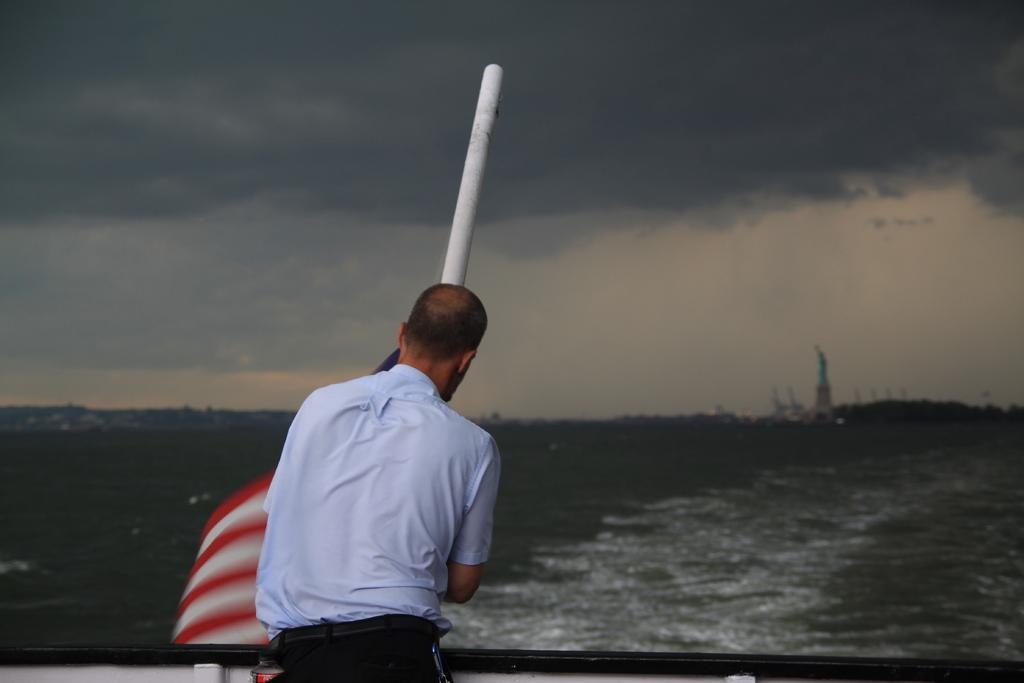Could you give a brief overview of what you see in this image? In this image I can see a man is standing. The man is wearing a shirt and a pant. In the background I can see water, a white color pole and the sky. 